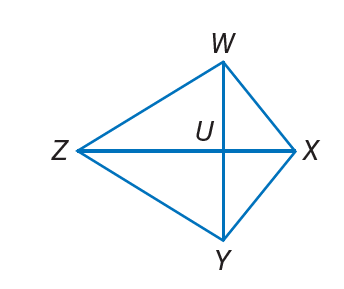Answer the mathemtical geometry problem and directly provide the correct option letter.
Question: W X Y Z is a kite. If m \angle W X Y = 120, m \angle W Z Y = 4 x, and m \angle Z W X = 10 x, find m \angle Z Y X.
Choices: A: 24 B: 40 C: 60 D: 100 D 